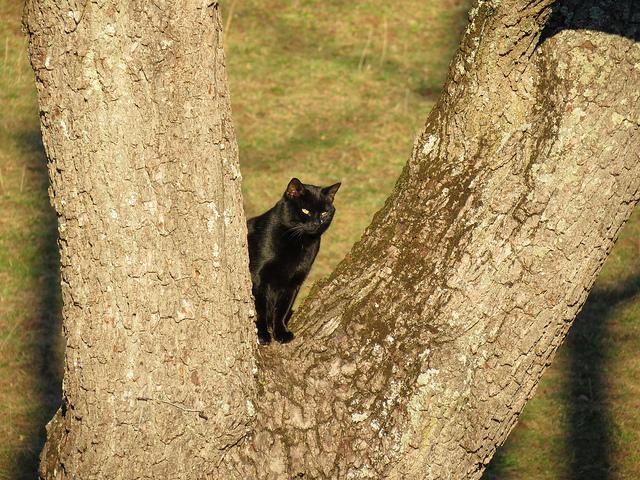Does the animal have teeth?
Answer briefly. Yes. Is the animal sleeping?
Answer briefly. No. What color is cat?
Short answer required. Black. 